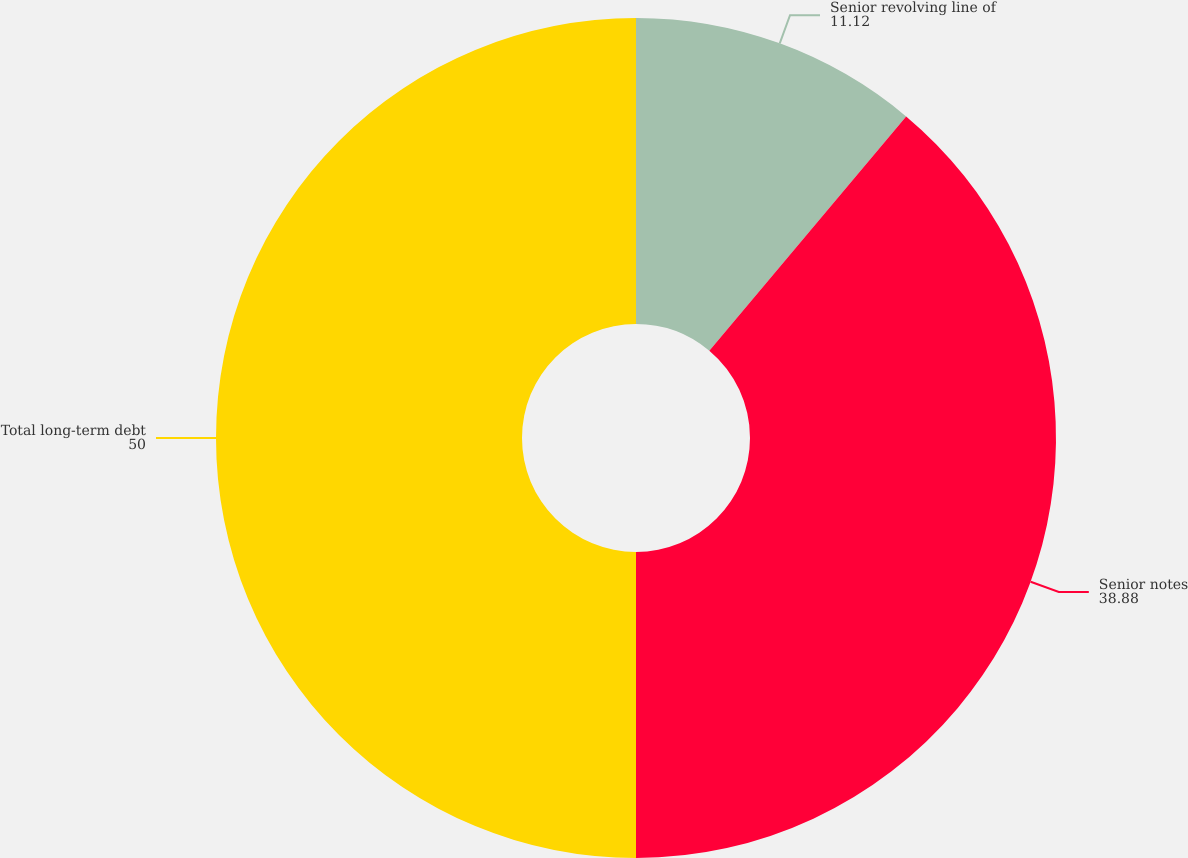<chart> <loc_0><loc_0><loc_500><loc_500><pie_chart><fcel>Senior revolving line of<fcel>Senior notes<fcel>Total long-term debt<nl><fcel>11.12%<fcel>38.88%<fcel>50.0%<nl></chart> 